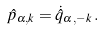Convert formula to latex. <formula><loc_0><loc_0><loc_500><loc_500>\hat { p } _ { \alpha , { k } } = \dot { \hat { q } } _ { \alpha , { - k } } \, .</formula> 